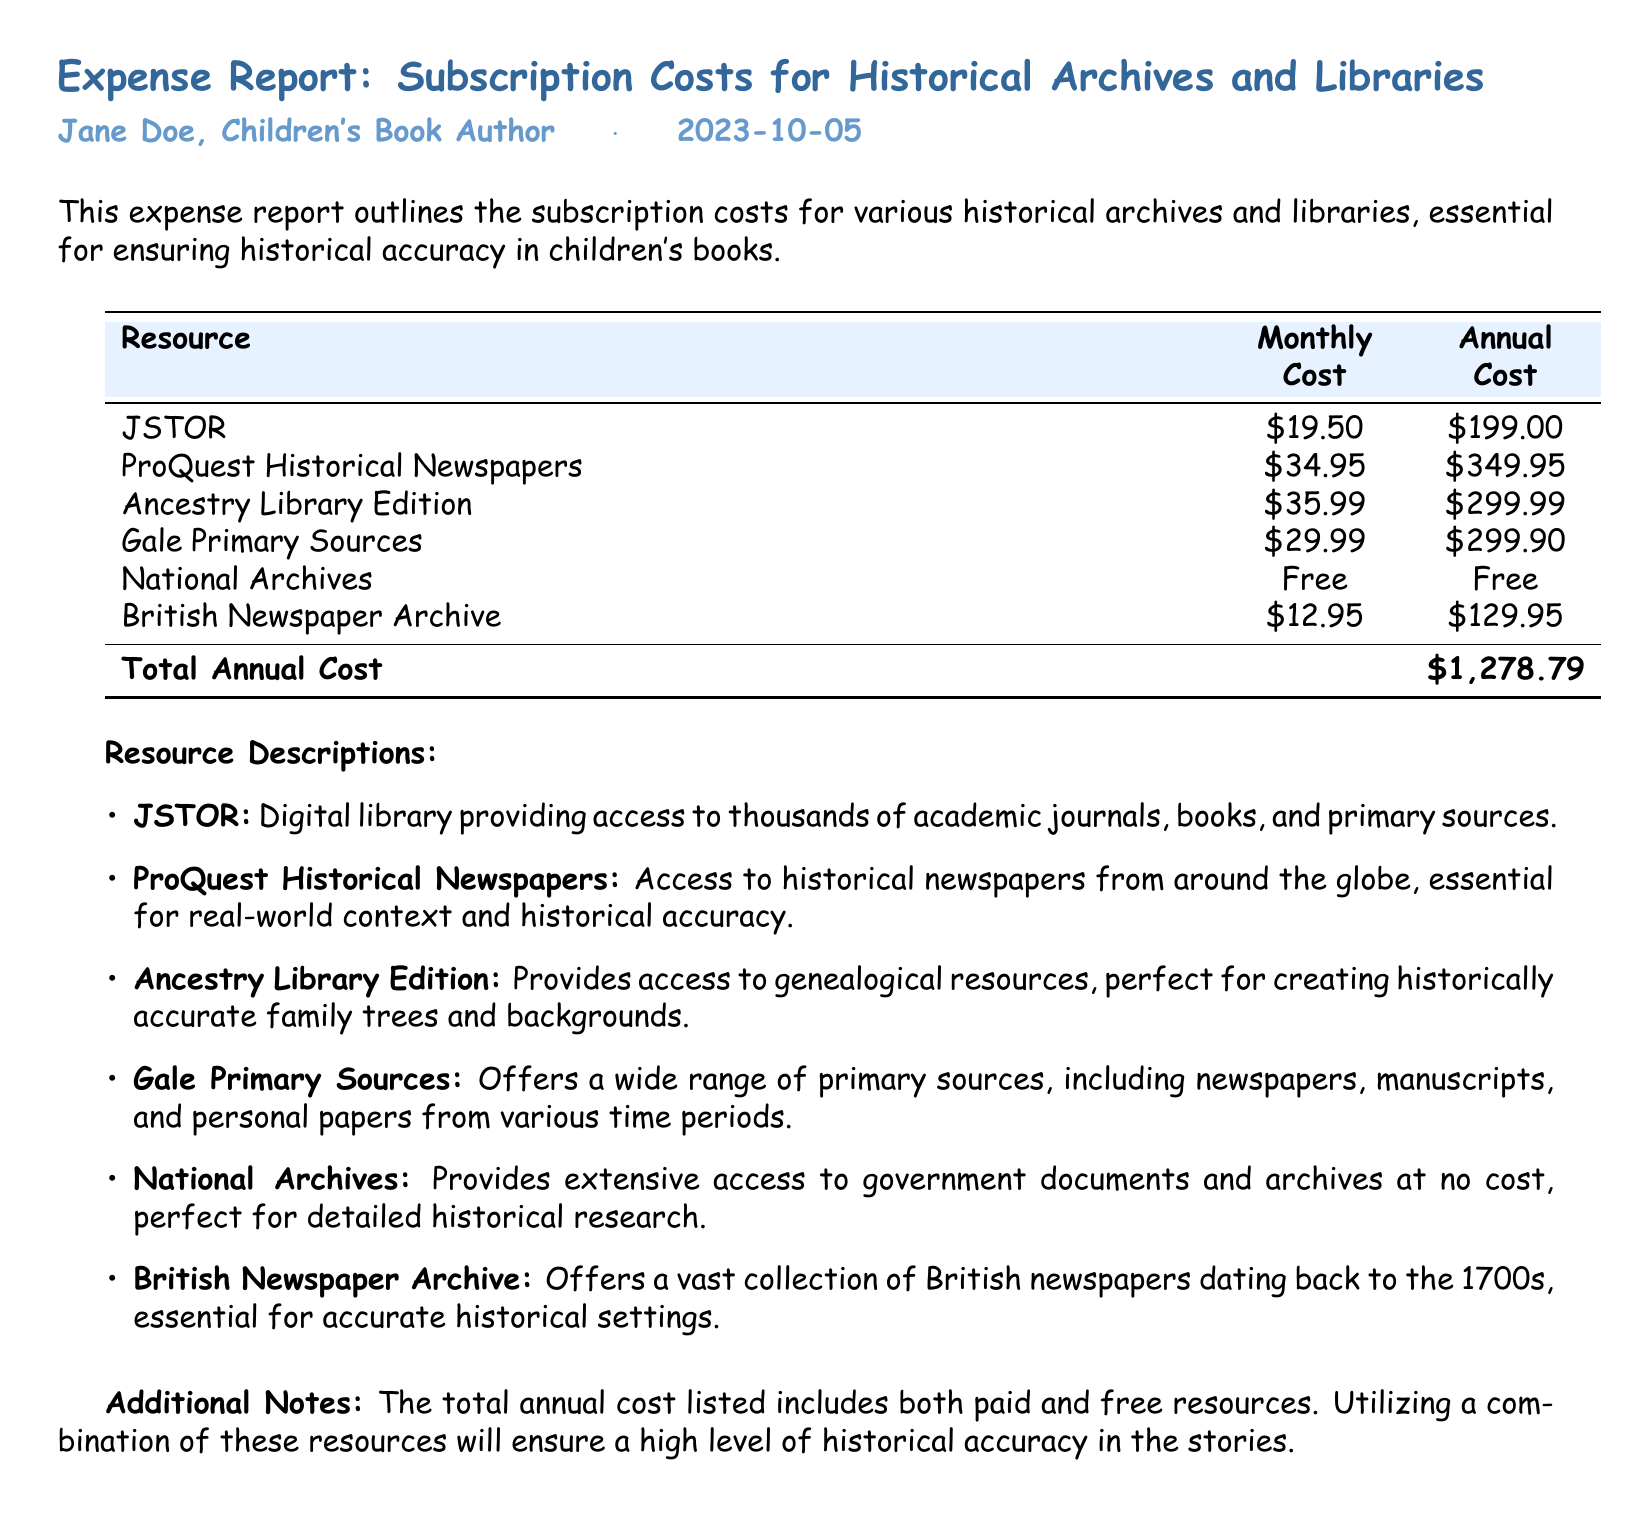What is the total annual cost? The total annual cost is listed at the bottom of the document, summing all the annual subscription costs for the listed resources.
Answer: $1,278.79 How much does JSTOR cost monthly? The document lists the monthly cost for JSTOR under the "Monthly Cost" column.
Answer: $19.50 What is a free resource listed in the report? The report identifies resources with zero cost, indicating the availability of free options.
Answer: National Archives Which resource costs the most annually? This requires comparing all the annual costs and identifying the highest one presented in the table.
Answer: ProQuest Historical Newspapers How many resources are listed in total? The document includes a specific number of resources, including those that are free and paid.
Answer: 6 What does Ancestry Library Edition provide access to? The document describes what Ancestry Library Edition offers under the resource descriptions section, highlighting its usefulness for historical accuracy.
Answer: Genealogical resources What is the monthly cost of the British Newspaper Archive? You can find the monthly cost listed next to British Newspaper Archive in the table.
Answer: $12.95 How many resources have an annual cost of under $200? To find this, you count resources from the table that have annual costs below this threshold.
Answer: 3 What types of documents does Gale Primary Sources include? The description of Gale Primary Sources specifies what kinds of primary sources it offers, relating to the types useful for research.
Answer: Newspapers, manuscripts, personal papers 